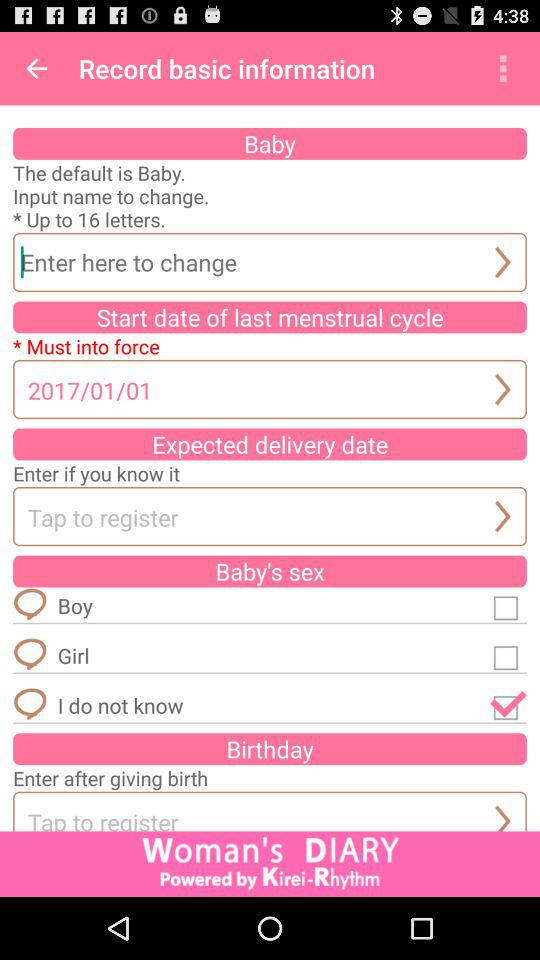What is the start date of the last menstrual cycle? The start date is 2017/01/01. 